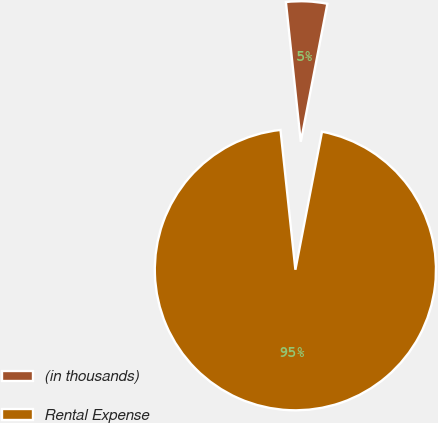Convert chart. <chart><loc_0><loc_0><loc_500><loc_500><pie_chart><fcel>(in thousands)<fcel>Rental Expense<nl><fcel>4.72%<fcel>95.28%<nl></chart> 